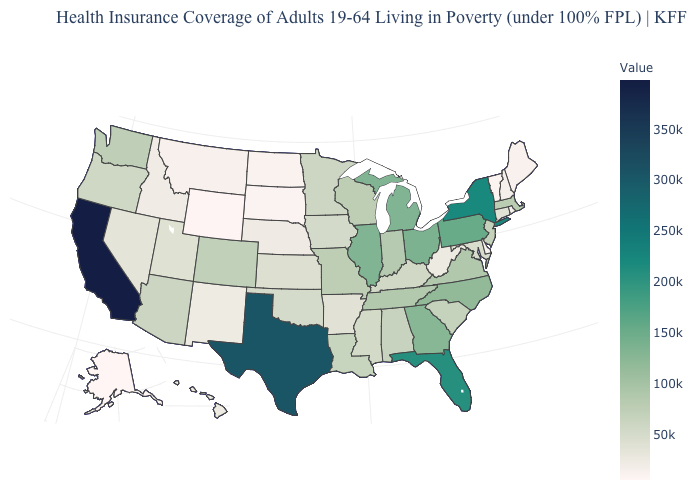Does South Carolina have a higher value than Hawaii?
Concise answer only. Yes. Does Alaska have the lowest value in the West?
Short answer required. Yes. Does Oklahoma have the lowest value in the South?
Short answer required. No. Among the states that border Kansas , which have the lowest value?
Be succinct. Nebraska. 